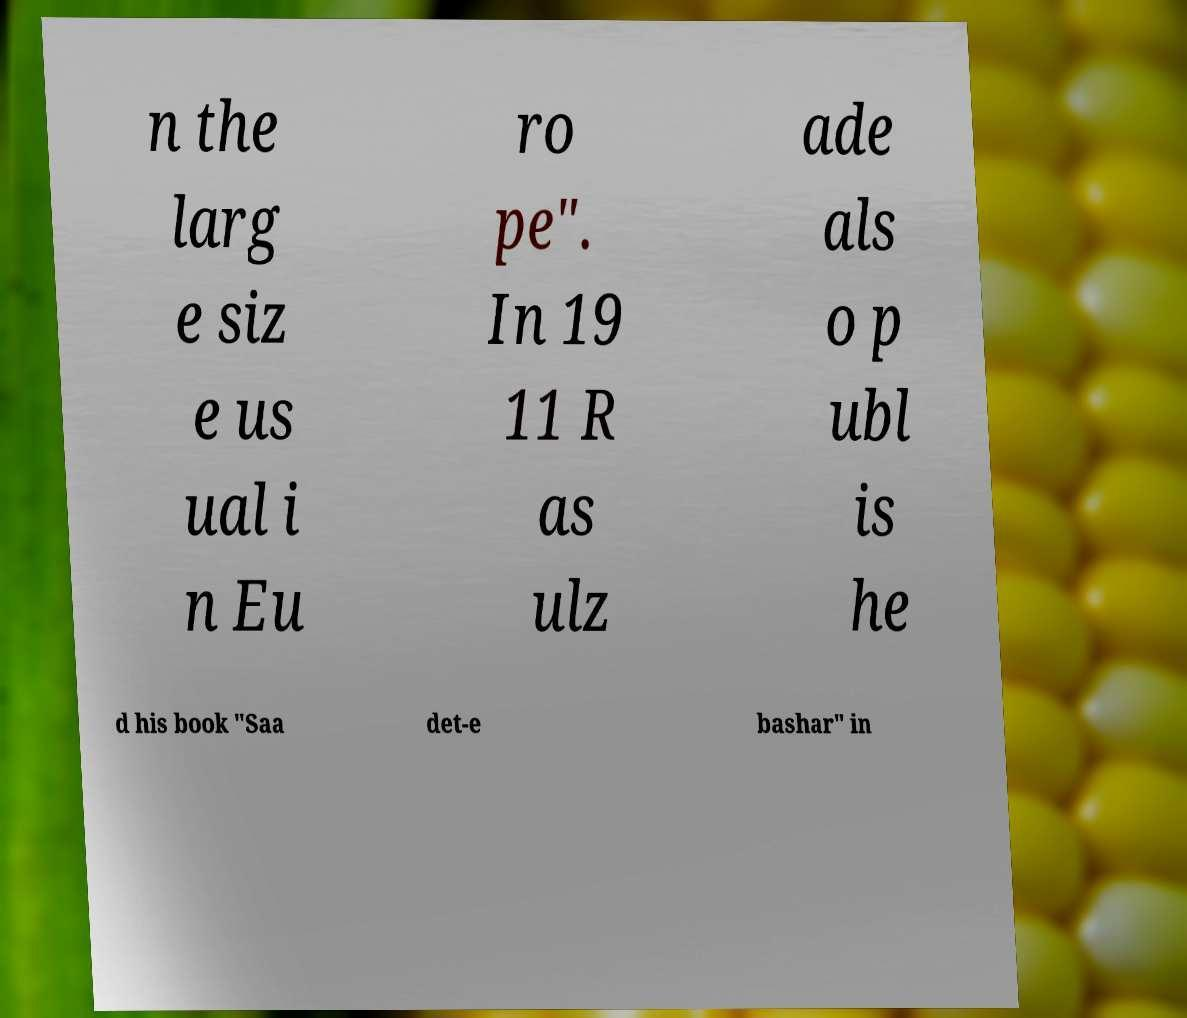What messages or text are displayed in this image? I need them in a readable, typed format. n the larg e siz e us ual i n Eu ro pe". In 19 11 R as ulz ade als o p ubl is he d his book "Saa det-e bashar" in 